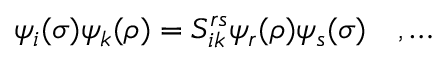<formula> <loc_0><loc_0><loc_500><loc_500>\psi _ { i } ( \sigma ) \psi _ { k } ( \rho ) = S _ { i k } ^ { r s } \psi _ { r } ( \rho ) \psi _ { s } ( \sigma ) \quad , \dots</formula> 